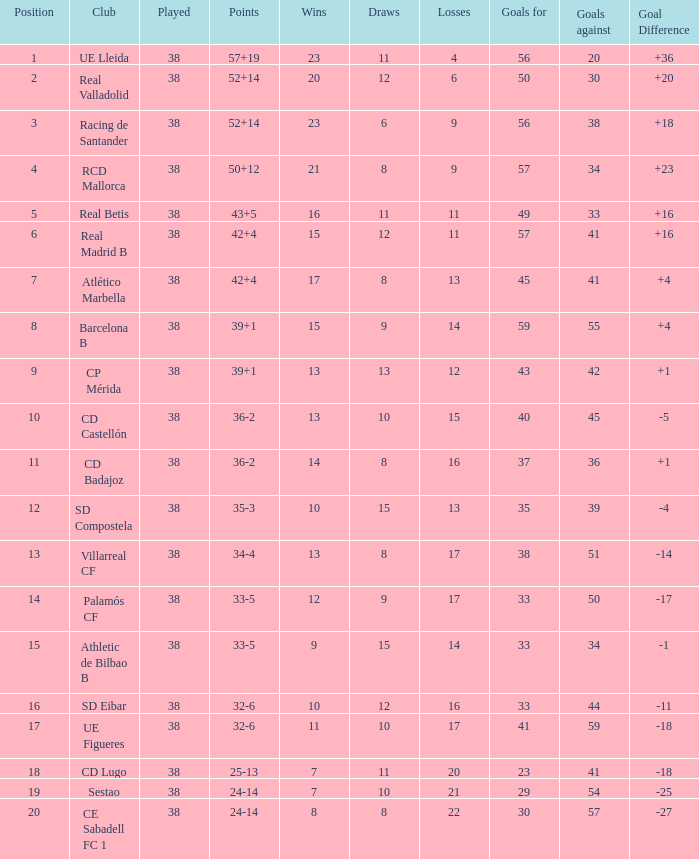What is the lowest position with 32-6 points and less then 59 goals when there are more than 38 played? None. 